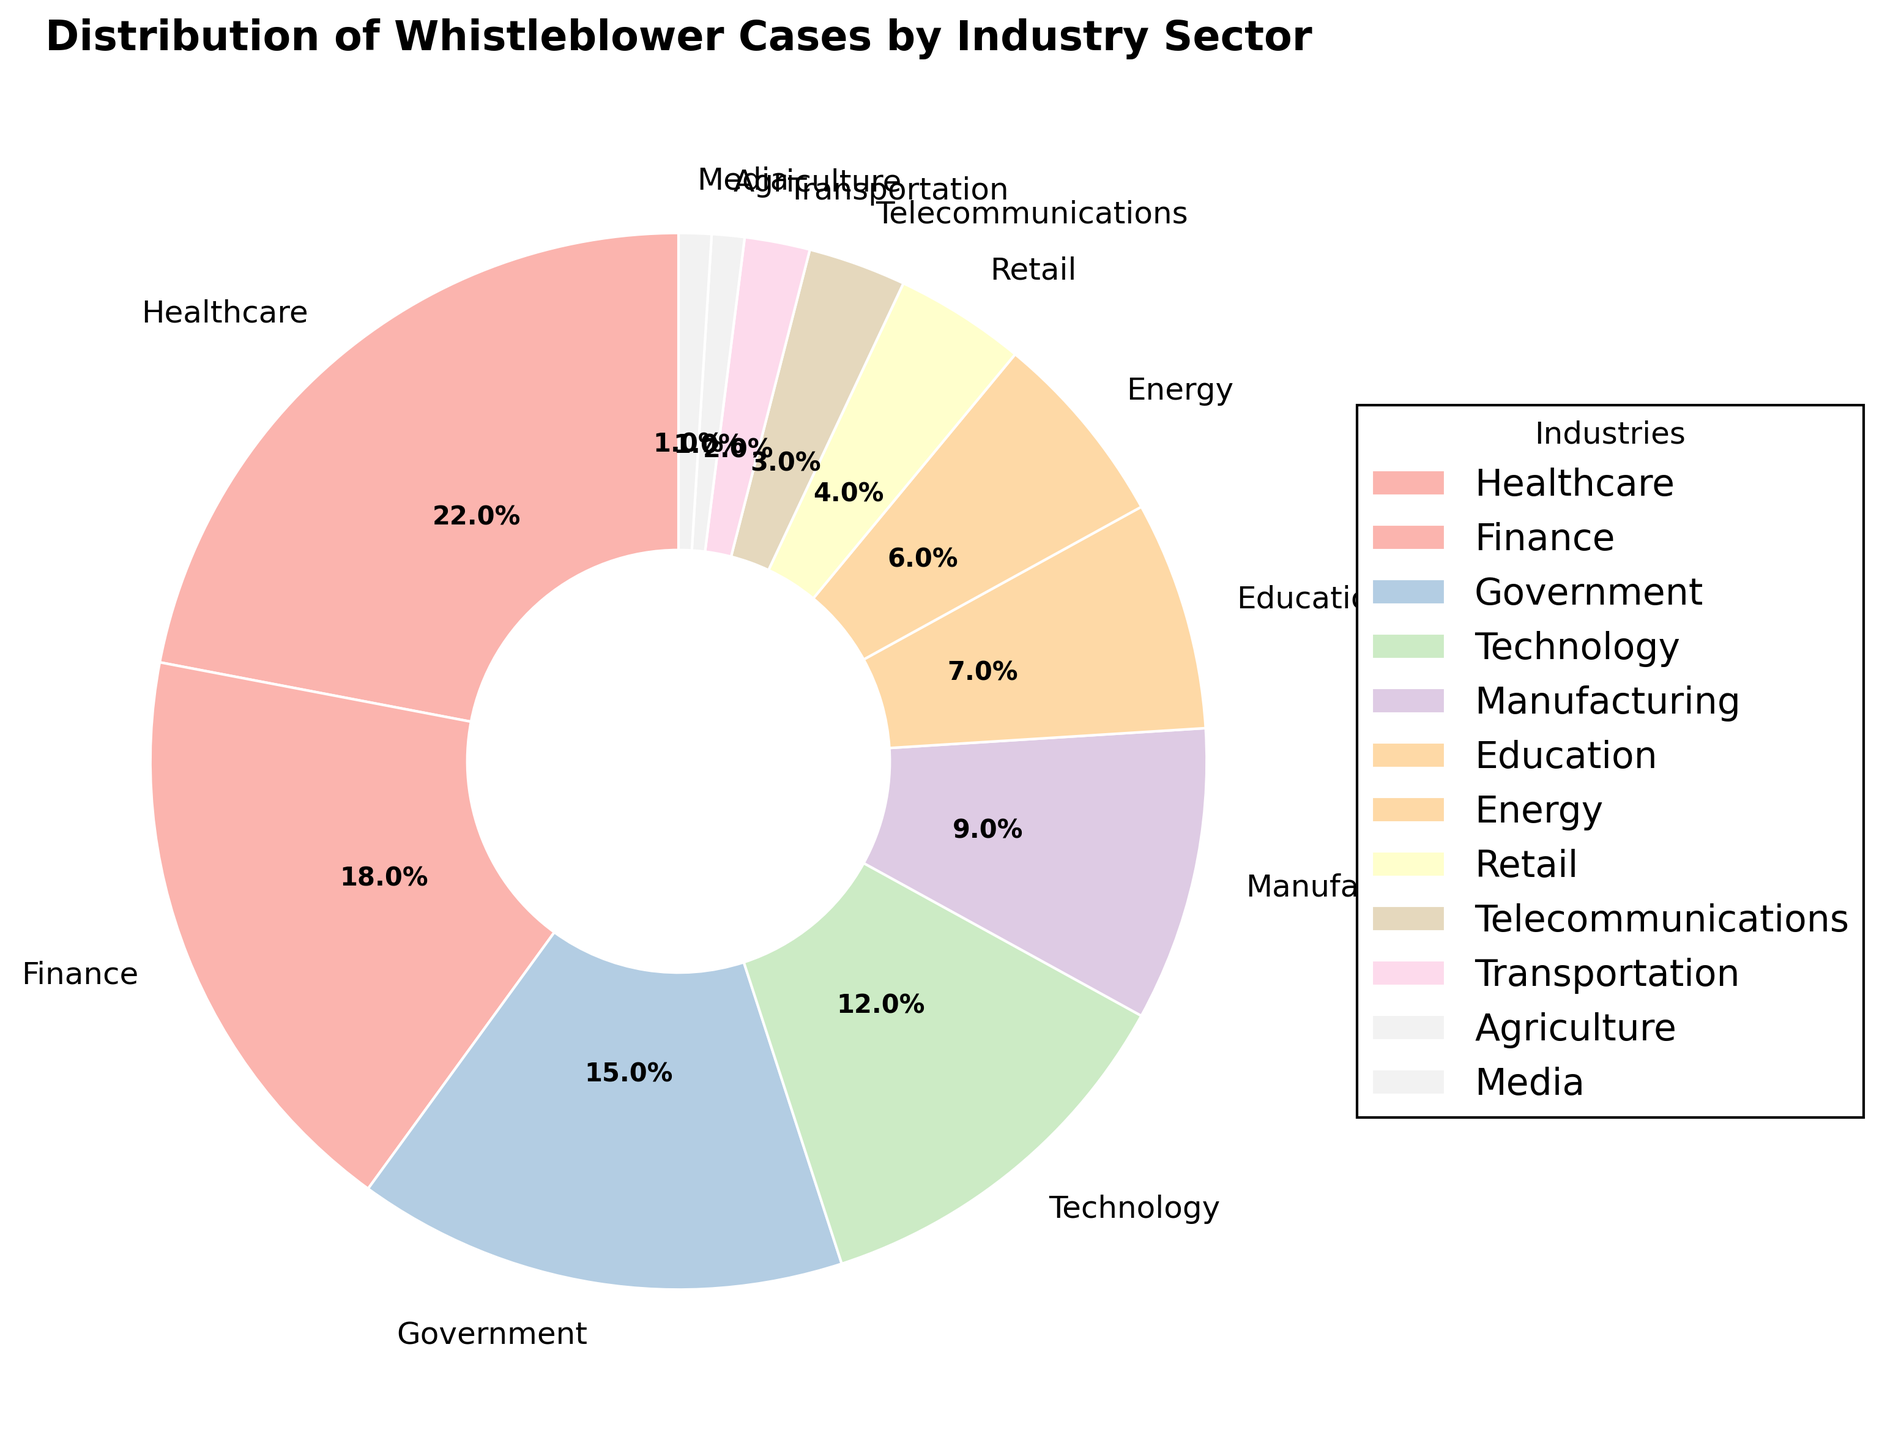What's the largest industry sector for whistleblower cases? The pie chart shows the percentages, and the largest slice corresponds to the largest industry sector. The Healthcare sector has the largest slice at 22%.
Answer: Healthcare Which industry has the second highest percentage of whistleblower cases? Look at the pie chart to identify the second largest slice. The Finance sector has the second highest percentage at 18%.
Answer: Finance What is the combined percentage of whistleblower cases in the Healthcare, Finance, and Government sectors? Sum the percentages for these three sectors: 22% (Healthcare) + 18% (Finance) + 15% (Government) = 55%.
Answer: 55% Which sectors have less than 5% of the total whistleblower cases? The pie chart shows the segments for each sector, and those less than 5% are Transportation (2%), Agriculture (1%), and Media (1%).
Answer: Transportation, Agriculture, Media How much more percentage does the Healthcare sector have compared to the Telecommunications sector? Subtract the percentage of Telecommunications from Healthcare: 22% (Healthcare) - 3% (Telecommunications) = 19%.
Answer: 19% What percentage of whistleblower cases are in the Technology and Retail sectors combined? Add the percentages for Technology and Retail: 12% (Technology) + 4% (Retail) = 16%.
Answer: 16% Which sector ranks fifth in terms of whistleblower cases? By observing the size and percentage labels in descending order, Manufacturing stands as the fifth sector with 9%.
Answer: Manufacturing What is the total percentage of whistleblower cases in the sectors with more than 10% each? Sum the percentages of sectors with more than 10%: Healthcare (22%), Finance (18%), Government (15%), Technology (12%) = 67%.
Answer: 67% By how much does the Government sector exceed the Manufacturing sector in terms of whistleblower cases? Subtract the percentage of Manufacturing from Government: 15% (Government) - 9% (Manufacturing) = 6%.
Answer: 6% What percentage of whistleblower cases are in sectors outside the top five largest? Sum the percentages of the sectors outside the top five: Education (7%) + Energy (6%) + Retail (4%) + Telecommunications (3%) + Transportation (2%) + Agriculture (1%) + Media (1%) = 24%.
Answer: 24% 